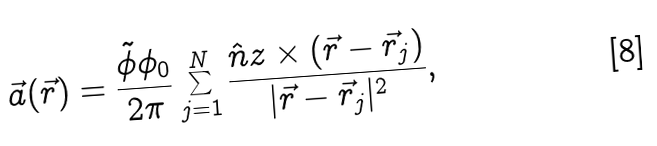<formula> <loc_0><loc_0><loc_500><loc_500>\vec { a } ( \vec { r } ) = \frac { \tilde { \phi } \phi _ { 0 } } { 2 \pi } \sum _ { j = 1 } ^ { N } \frac { \hat { n } { z } \times ( \vec { r } - \vec { r } _ { j } ) } { | \vec { r } - \vec { r } _ { j } | ^ { 2 } } ,</formula> 